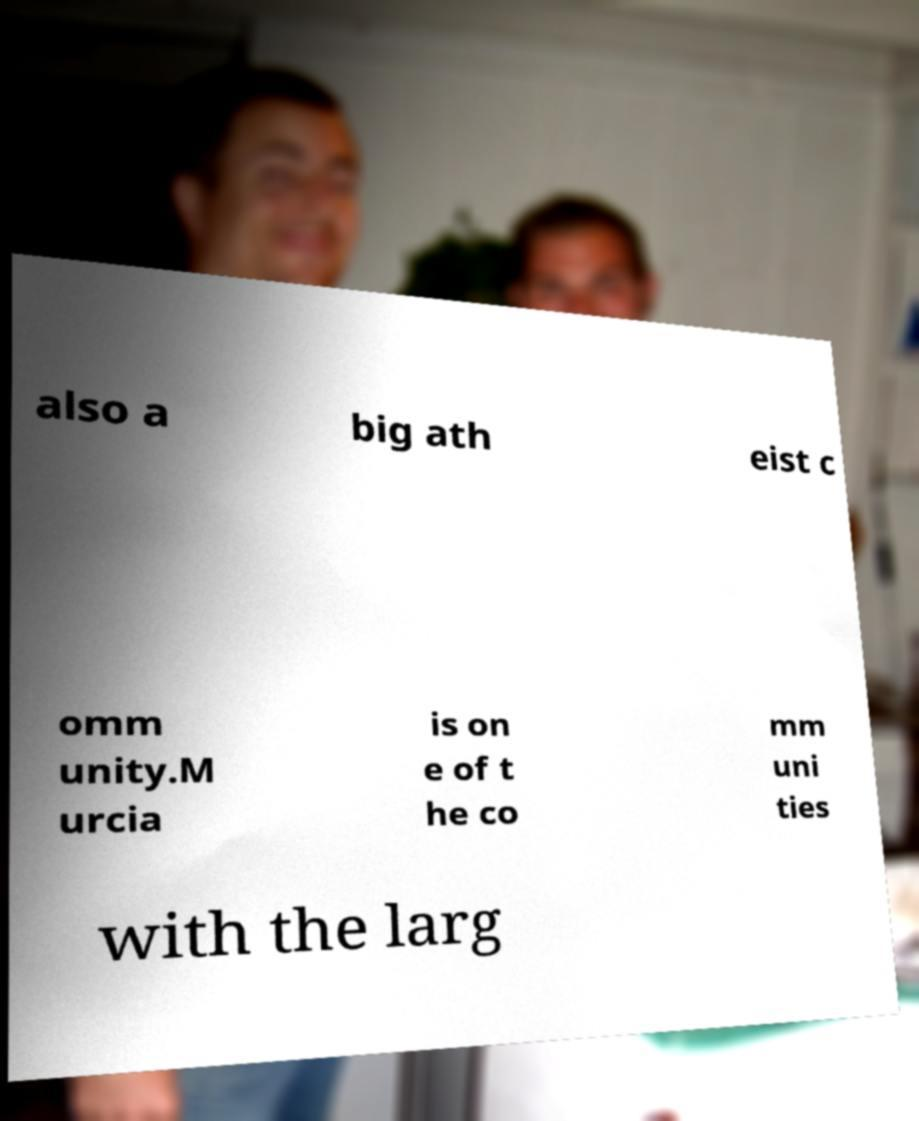For documentation purposes, I need the text within this image transcribed. Could you provide that? also a big ath eist c omm unity.M urcia is on e of t he co mm uni ties with the larg 